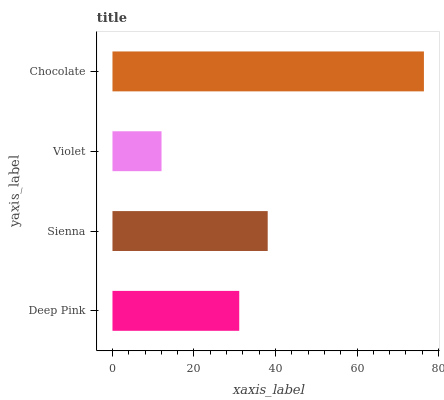Is Violet the minimum?
Answer yes or no. Yes. Is Chocolate the maximum?
Answer yes or no. Yes. Is Sienna the minimum?
Answer yes or no. No. Is Sienna the maximum?
Answer yes or no. No. Is Sienna greater than Deep Pink?
Answer yes or no. Yes. Is Deep Pink less than Sienna?
Answer yes or no. Yes. Is Deep Pink greater than Sienna?
Answer yes or no. No. Is Sienna less than Deep Pink?
Answer yes or no. No. Is Sienna the high median?
Answer yes or no. Yes. Is Deep Pink the low median?
Answer yes or no. Yes. Is Violet the high median?
Answer yes or no. No. Is Chocolate the low median?
Answer yes or no. No. 